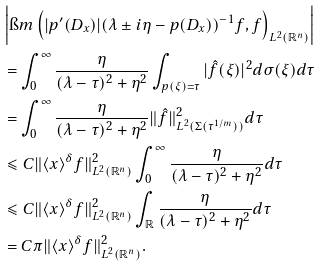<formula> <loc_0><loc_0><loc_500><loc_500>& \left | \i m \left ( | { p ^ { \prime } ( D _ { x } ) } | ( \lambda \pm { i } \eta - p ( D _ { x } ) ) ^ { - 1 } f , f \right ) _ { L ^ { 2 } ( \mathbb { R } ^ { n } ) } \right | \\ & = \int _ { 0 } ^ { \infty } \frac { \eta } { ( \lambda - \tau ) ^ { 2 } + \eta ^ { 2 } } \int _ { p ( \xi ) = \tau } | \hat { f } ( \xi ) | ^ { 2 } d \sigma ( \xi ) d \tau \\ & = \int _ { 0 } ^ { \infty } \frac { \eta } { ( \lambda - \tau ) ^ { 2 } + \eta ^ { 2 } } \| \hat { f } \| _ { L ^ { 2 } ( \Sigma ( \tau ^ { 1 / m } ) ) } ^ { 2 } d \tau \\ & \leqslant C \| \langle { x } \rangle ^ { \delta } { f } \| _ { L ^ { 2 } ( \mathbb { R } ^ { n } ) } ^ { 2 } \int _ { 0 } ^ { \infty } \frac { \eta } { ( \lambda - \tau ) ^ { 2 } + \eta ^ { 2 } } d \tau \\ & \leqslant C \| \langle { x } \rangle ^ { \delta } { f } \| _ { L ^ { 2 } ( \mathbb { R } ^ { n } ) } ^ { 2 } \int _ { \mathbb { R } } \frac { \eta } { ( \lambda - \tau ) ^ { 2 } + \eta ^ { 2 } } d \tau \\ & = C \pi \| \langle { x } \rangle ^ { \delta } { f } \| _ { L ^ { 2 } ( \mathbb { R } ^ { n } ) } ^ { 2 } .</formula> 